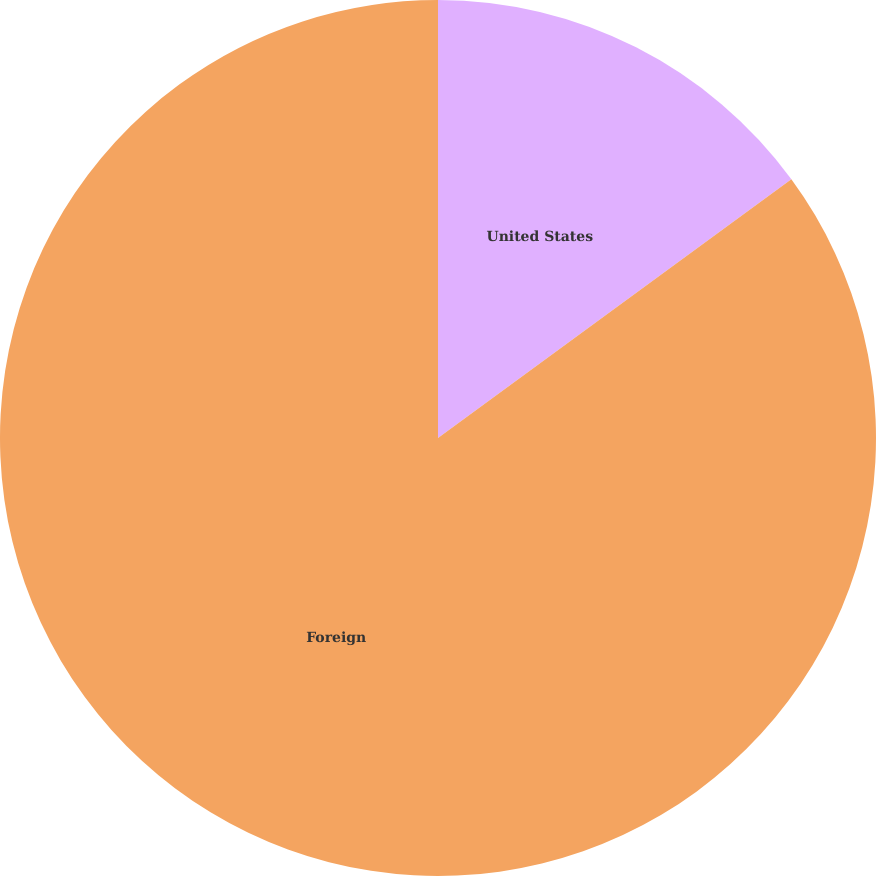Convert chart. <chart><loc_0><loc_0><loc_500><loc_500><pie_chart><fcel>United States<fcel>Foreign<nl><fcel>14.94%<fcel>85.06%<nl></chart> 